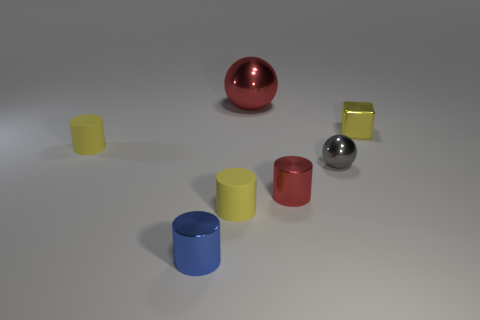What is the shape of the tiny yellow matte object that is in front of the gray metallic thing in front of the block?
Your answer should be compact. Cylinder. Do the blue thing and the tiny red shiny thing have the same shape?
Make the answer very short. Yes. What material is the thing that is the same color as the big sphere?
Ensure brevity in your answer.  Metal. Is the small sphere the same color as the large metallic thing?
Give a very brief answer. No. There is a yellow rubber object behind the metallic cylinder right of the large red thing; what number of small matte cylinders are in front of it?
Ensure brevity in your answer.  1. There is a tiny blue thing that is the same material as the large object; what is its shape?
Provide a short and direct response. Cylinder. There is a blue thing in front of the large ball that is behind the tiny yellow matte object that is to the right of the blue object; what is its material?
Make the answer very short. Metal. What number of things are either red metallic things right of the big red shiny thing or tiny purple spheres?
Your answer should be compact. 1. What number of other things are there of the same shape as the small red metal thing?
Your response must be concise. 3. Is the number of things that are on the right side of the blue object greater than the number of blue cylinders?
Ensure brevity in your answer.  Yes. 